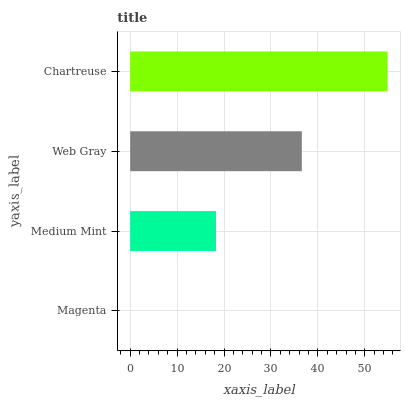Is Magenta the minimum?
Answer yes or no. Yes. Is Chartreuse the maximum?
Answer yes or no. Yes. Is Medium Mint the minimum?
Answer yes or no. No. Is Medium Mint the maximum?
Answer yes or no. No. Is Medium Mint greater than Magenta?
Answer yes or no. Yes. Is Magenta less than Medium Mint?
Answer yes or no. Yes. Is Magenta greater than Medium Mint?
Answer yes or no. No. Is Medium Mint less than Magenta?
Answer yes or no. No. Is Web Gray the high median?
Answer yes or no. Yes. Is Medium Mint the low median?
Answer yes or no. Yes. Is Magenta the high median?
Answer yes or no. No. Is Chartreuse the low median?
Answer yes or no. No. 